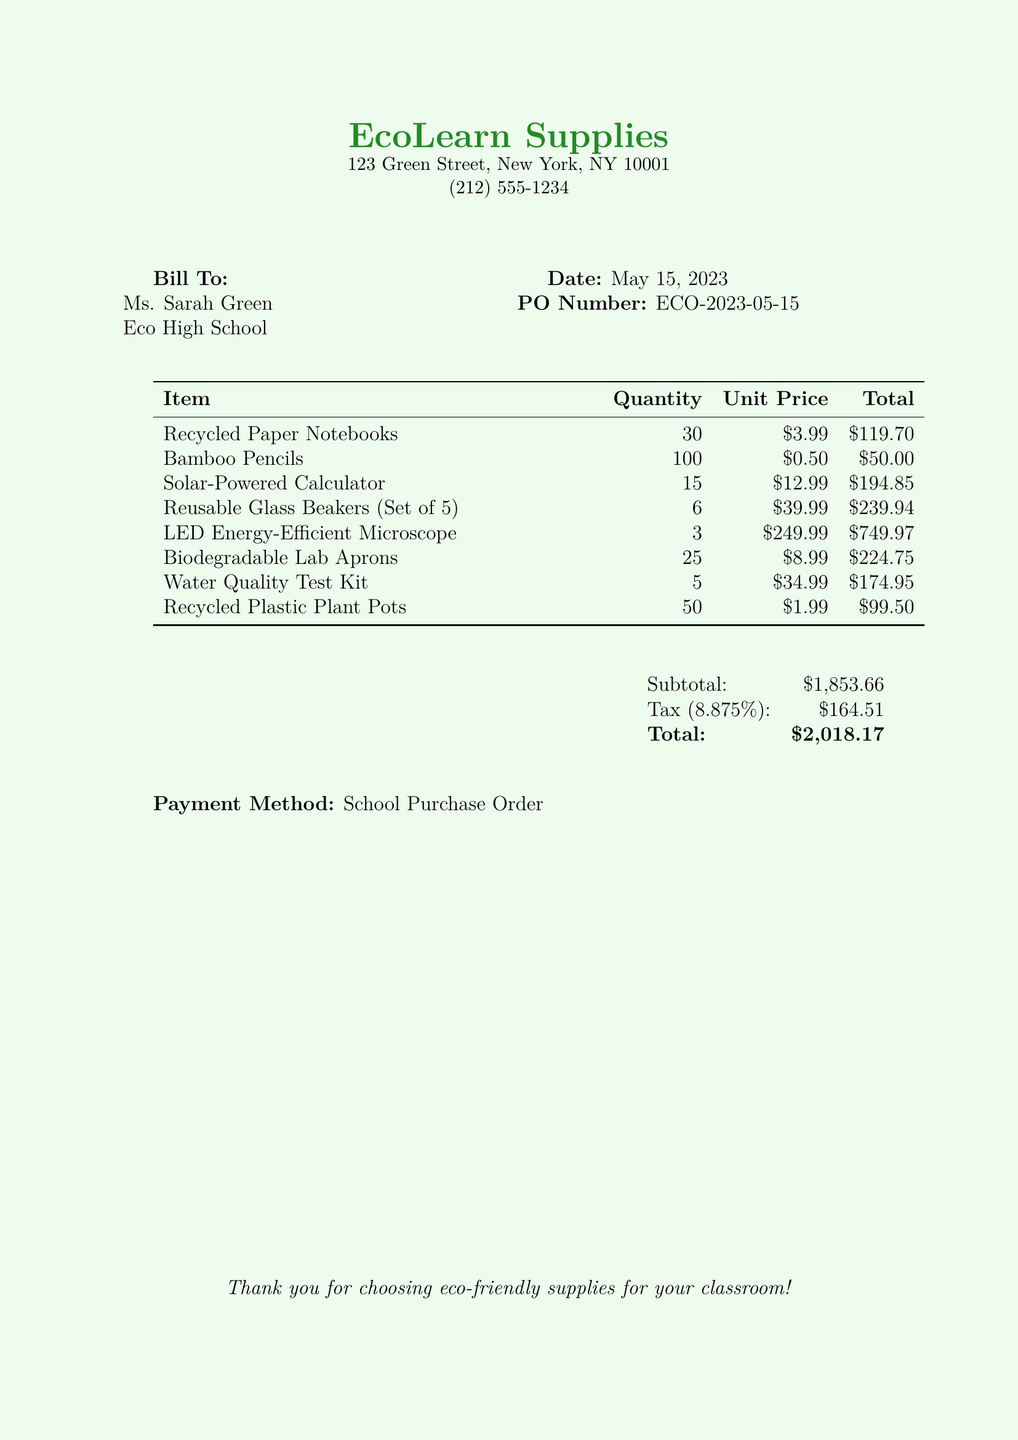What is the date of the bill? The date of the bill is stated in the document as May 15, 2023.
Answer: May 15, 2023 Who is the bill addressed to? The bill is addressed to Ms. Sarah Green at Eco High School.
Answer: Ms. Sarah Green How many Bamboo Pencils were purchased? The number of Bamboo Pencils purchased is indicated as 100 in the document.
Answer: 100 What is the subtotal amount? The subtotal amount is clearly listed in the document as $1,853.66.
Answer: $1,853.66 What is the tax rate applied to the purchase? The tax rate is shown as 8.875% in the document.
Answer: 8.875% How many Solar-Powered Calculators were purchased? The quantity of Solar-Powered Calculators purchased is mentioned as 15.
Answer: 15 What is the total amount due? The total amount due, including tax, is explicitly noted as $2,018.17.
Answer: $2,018.17 What type of payment method was used for this bill? The payment method used is stated as a School Purchase Order in the document.
Answer: School Purchase Order How many total items were listed in the bill? To find the total items, you can count from the table: there are 8 distinct items listed.
Answer: 8 